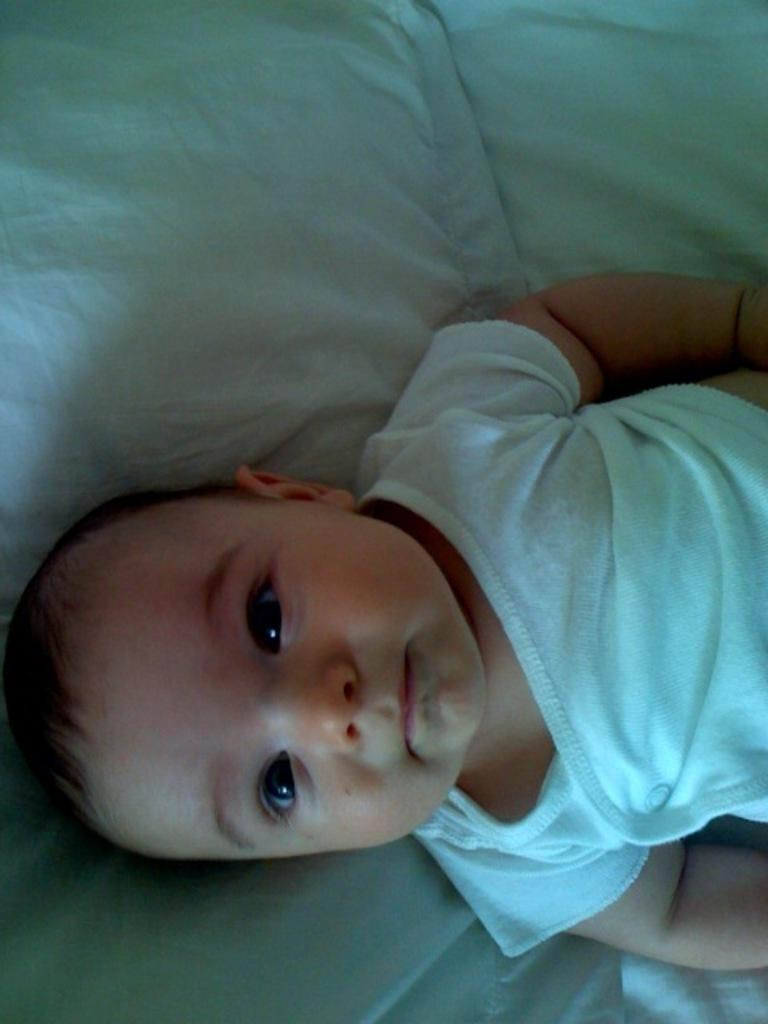What is the main subject of the picture? The main subject of the picture is a kid. What is the kid doing in the picture? The kid is lying on a bed. How is the bed decorated or covered? The bed is covered with a white cloth. How many monkeys are sitting on the bed with the kid in the picture? There are no monkeys present in the image; it only features a kid lying on a bed. What type of frogs can be seen hopping on the white cloth in the image? There are no frogs present in the image; the white cloth is covering the bed, and no frogs are visible. 